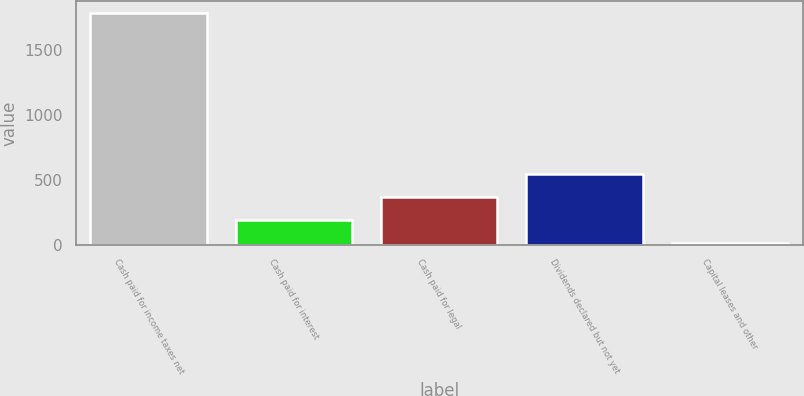Convert chart to OTSL. <chart><loc_0><loc_0><loc_500><loc_500><bar_chart><fcel>Cash paid for income taxes net<fcel>Cash paid for interest<fcel>Cash paid for legal<fcel>Dividends declared but not yet<fcel>Capital leases and other<nl><fcel>1790<fcel>188<fcel>366<fcel>544<fcel>10<nl></chart> 